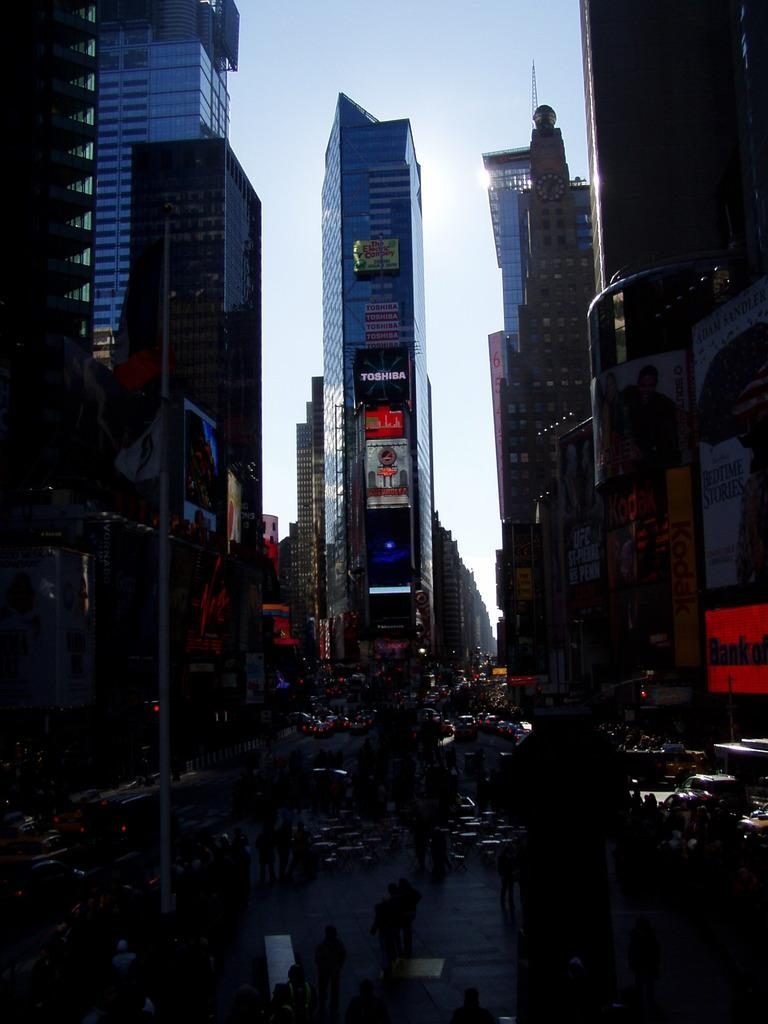What type of structures can be seen in the image? There are buildings in the image. What is happening on the road in the image? There are vehicles on the road in the image. What else can be found on the ground in the image? There are other objects on the ground in the image. What is visible in the background of the image? The sky is visible in the background of the image. How would you describe the lighting in the image? The image appears to be slightly dark. What type of marble is used to decorate the wrist of the person in the image? There is no person or wrist present in the image, and therefore no marble can be observed. How does the drain affect the flow of traffic in the image? There is no drain present in the image, so its effect on traffic cannot be determined. 